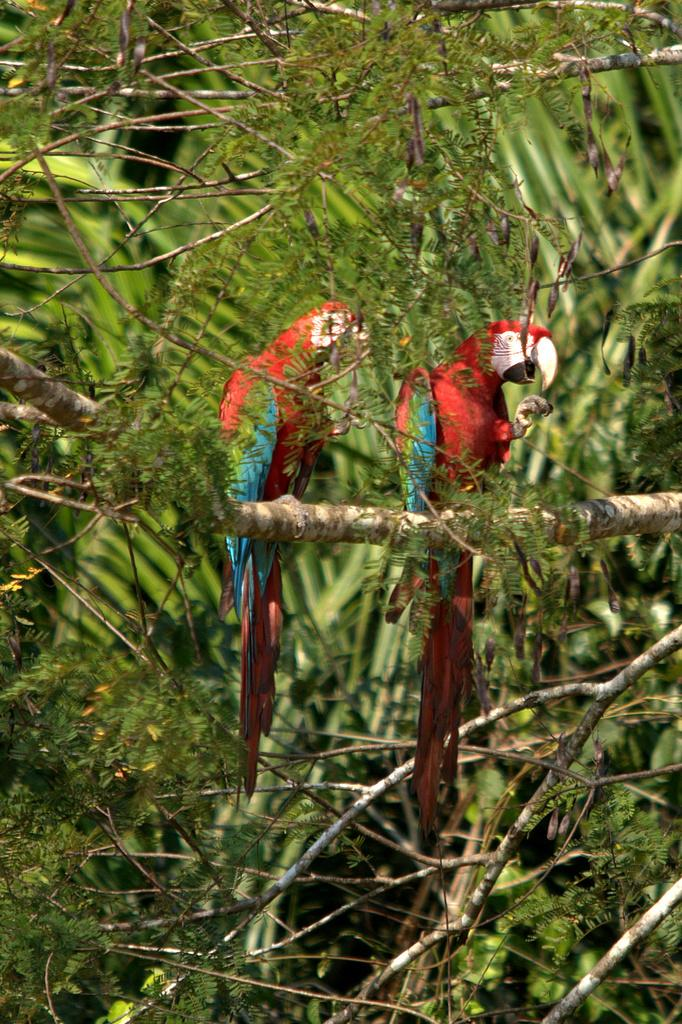What type of animals are in the image? There are two red color birds in the image. Where are the birds located? The birds are on a stem in the image. What else can be seen in the image besides the birds? Many leaves and stems are visible in the image. What type of skin care product is visible in the image? There is no skin care product present in the image. Where is the store located in the image? There is no store present in the image. 